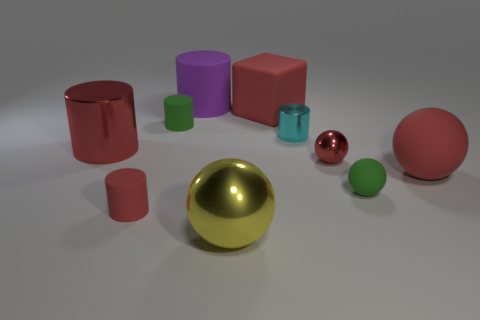Does the tiny green sphere have the same material as the large yellow thing?
Make the answer very short. No. Is there any other thing that has the same shape as the small cyan thing?
Offer a terse response. Yes. What material is the large sphere in front of the small matte cylinder in front of the tiny green cylinder made of?
Your response must be concise. Metal. What size is the green thing in front of the small green matte cylinder?
Give a very brief answer. Small. What is the color of the big thing that is on the right side of the big purple object and left of the matte block?
Offer a terse response. Yellow. There is a green rubber thing that is in front of the cyan cylinder; does it have the same size as the large purple cylinder?
Provide a short and direct response. No. There is a tiny matte cylinder that is behind the small cyan object; is there a matte cylinder that is behind it?
Your answer should be very brief. Yes. What is the purple object made of?
Your response must be concise. Rubber. There is a cyan shiny thing; are there any big purple things right of it?
Keep it short and to the point. No. There is a cyan metal thing that is the same shape as the large purple matte object; what size is it?
Your answer should be compact. Small. 